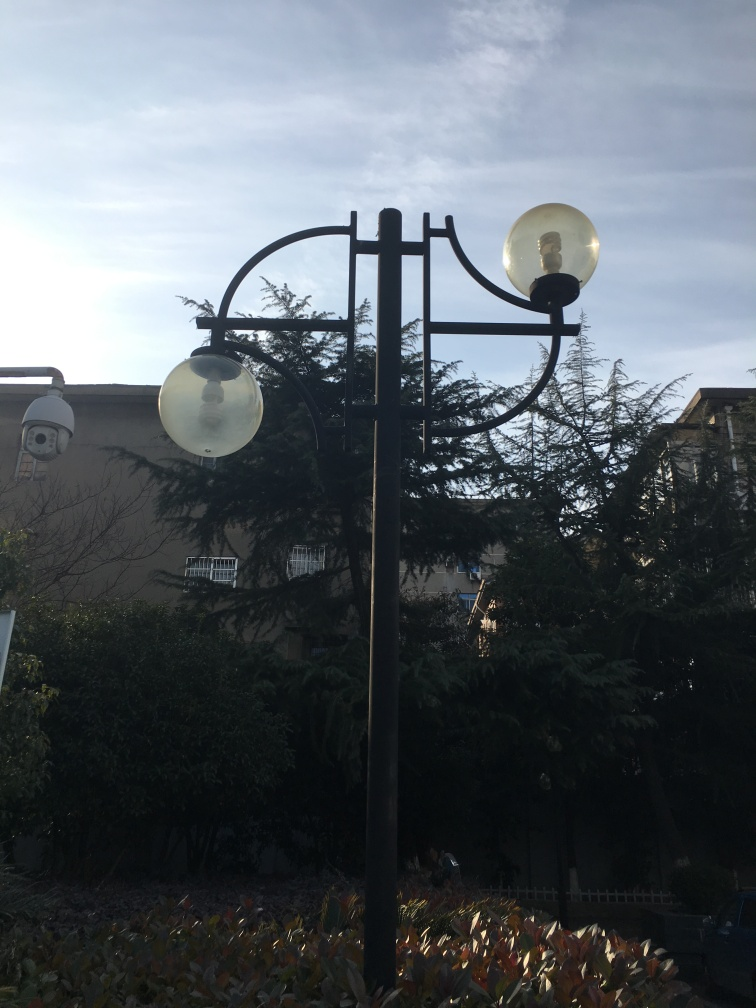What is the likely location of this image based on architectural and environmental clues? Based on the architecture of the buildings in the background, the presence of mature trees, and the design of the streetlamp, the image likely portrays a location within a well-established urban area with a temperate climate. The combination of residential and what may be perceived as older public structures suggests this could be in a suburb of a larger city in Europe or North America. 